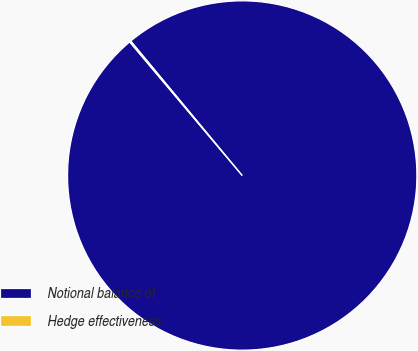Convert chart. <chart><loc_0><loc_0><loc_500><loc_500><pie_chart><fcel>Notional balance of<fcel>Hedge effectiveness<nl><fcel>99.88%<fcel>0.12%<nl></chart> 